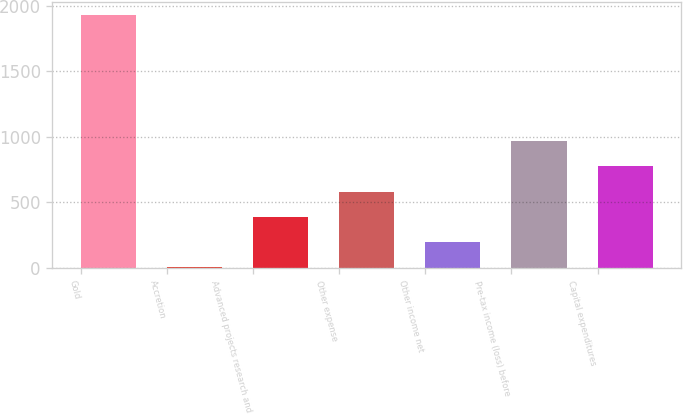<chart> <loc_0><loc_0><loc_500><loc_500><bar_chart><fcel>Gold<fcel>Accretion<fcel>Advanced projects research and<fcel>Other expense<fcel>Other income net<fcel>Pre-tax income (loss) before<fcel>Capital expenditures<nl><fcel>1929<fcel>6<fcel>390.6<fcel>582.9<fcel>198.3<fcel>967.5<fcel>775.2<nl></chart> 